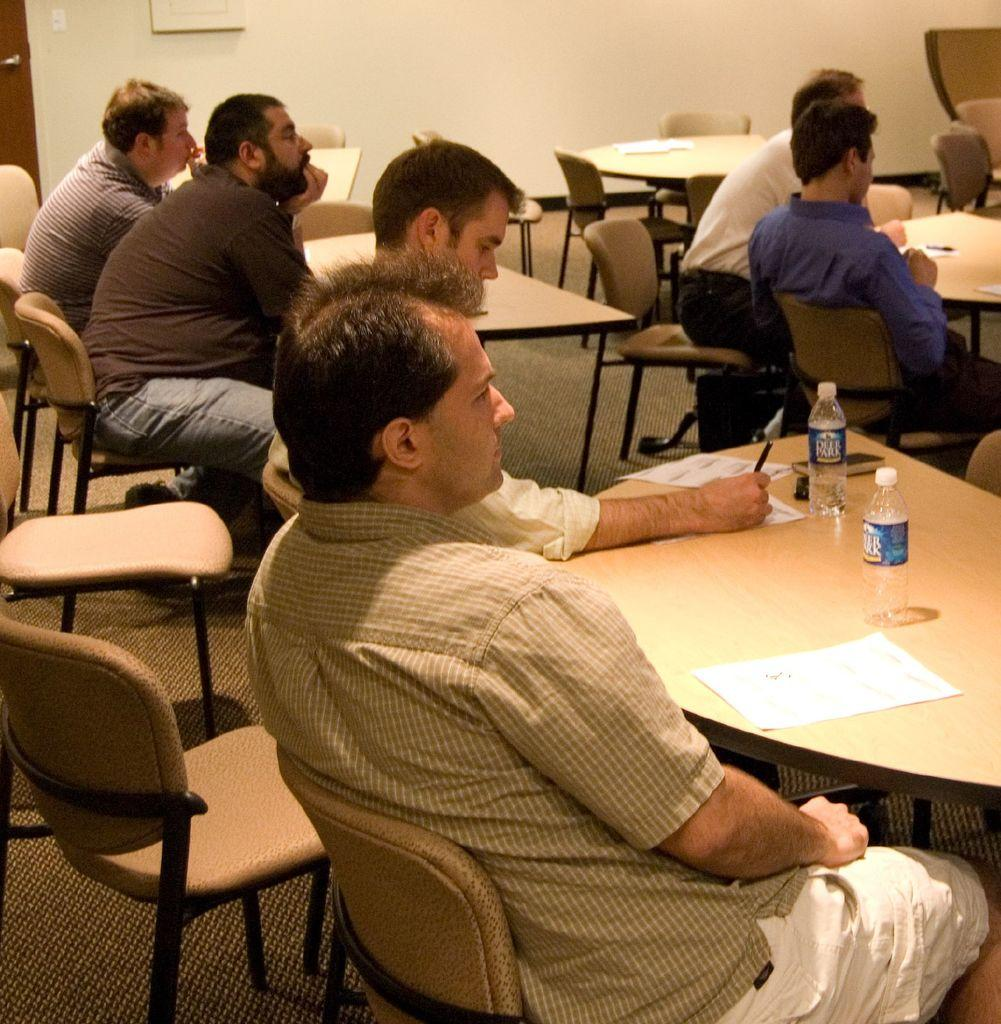What is the main subject of the image? The main subject of the image is a group of men. What are the men doing in the image? The men are sitting on chairs in the image. What is present on the table in front of the men? There is paper, bottles, and a remote on the table in the image. What can be seen in the background of the image? There is a wall, a door, and a frame in the background of the image. What type of robin can be seen perched on the frame in the background of the image? There is no robin present in the image; it only features a group of men, chairs, a table, and background elements. What season is depicted in the image, considering the presence of summer-related items? There is no specific season depicted in the image, as it does not contain any seasonal elements or items. 